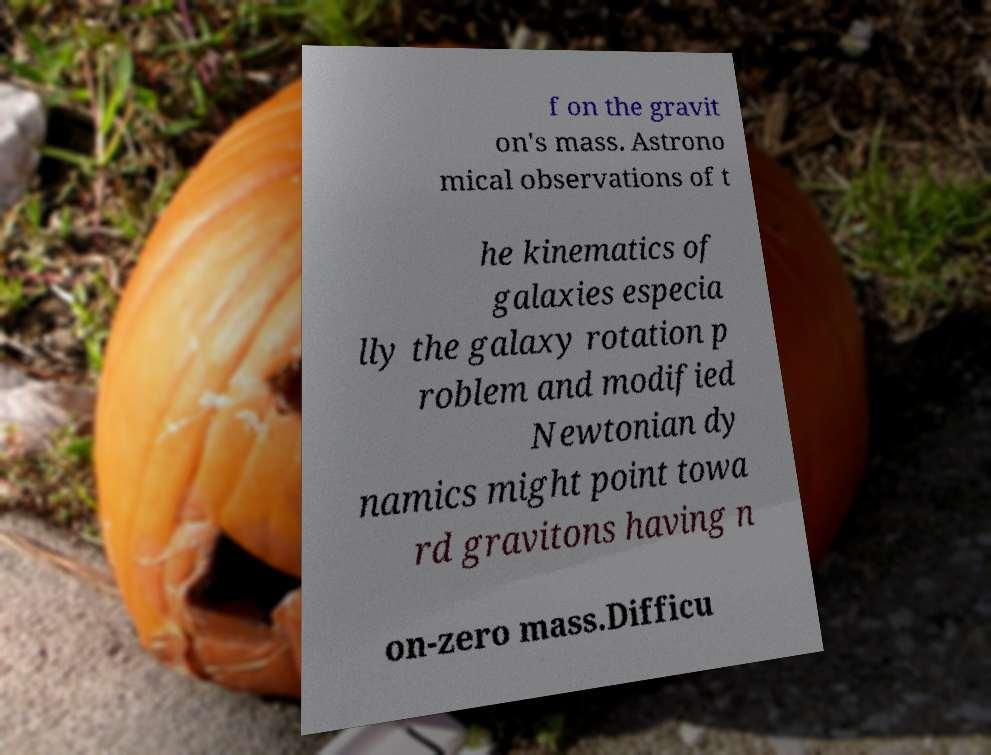Could you extract and type out the text from this image? f on the gravit on's mass. Astrono mical observations of t he kinematics of galaxies especia lly the galaxy rotation p roblem and modified Newtonian dy namics might point towa rd gravitons having n on-zero mass.Difficu 